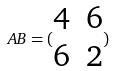Convert formula to latex. <formula><loc_0><loc_0><loc_500><loc_500>A B = ( \begin{matrix} 4 & 6 \\ 6 & 2 \end{matrix} )</formula> 